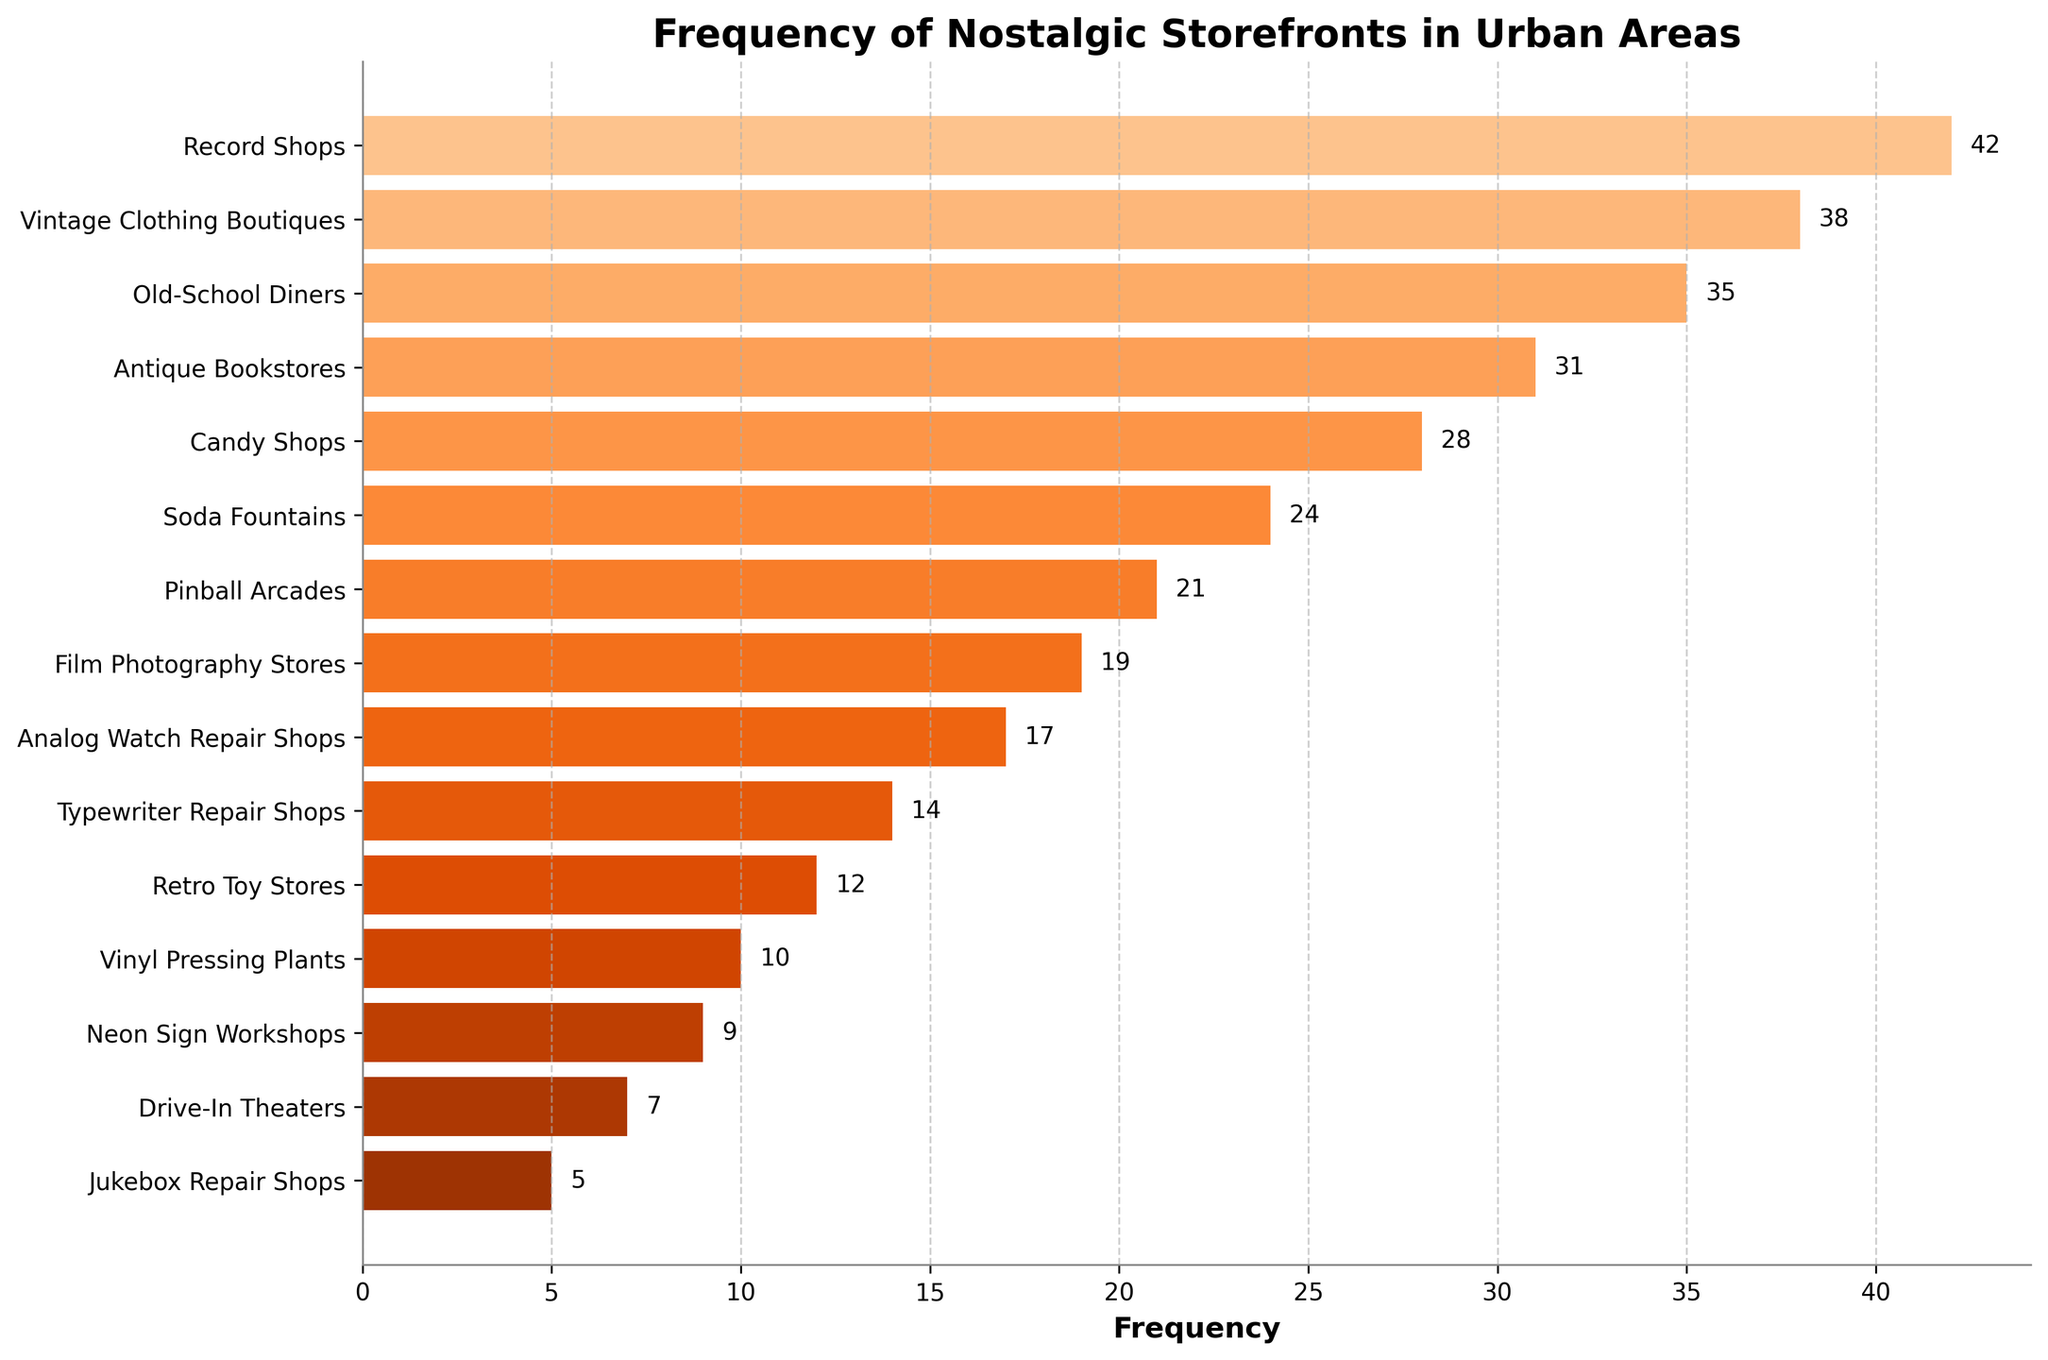What's the most frequent nostalgic storefront type captured? To find the most frequent storefront type, look for the bar with the greatest length. "Record Shops" have the highest frequency in the chart.
Answer: Record Shops Which storefront type has a lower frequency: "Candy Shops" or "Soda Fountains"? Compare the lengths of the bars for "Candy Shops" and "Soda Fountains". "Soda Fountains" has a shorter bar than "Candy Shops".
Answer: Soda Fountains How much greater is the frequency of "Old-School Diners" compared to "Analog Watch Repair Shops"? Subtract the frequency of "Analog Watch Repair Shops" (17) from the frequency of "Old-School Diners" (35): 35 - 17 = 18.
Answer: 18 What’s the average frequency of the top three most frequent nostalgic storefronts? The frequencies of the top three most frequent storefronts are: Record Shops (42), Vintage Clothing Boutiques (38), and Old-School Diners (35). Their sum is 42 + 38 + 35 = 115. The average is 115 / 3 = 38.33.
Answer: 38.33 Identify two storefront types whose combined frequency equals that of "Pinball Arcades". "Pinball Arcades" has a frequency of 21. "Typewriter Repair Shops" (14) and "Analog Watch Repair Shops" (17) can be checked: 14 + 17 = 31 (too high), "Candy Shops" (28) and "Typewriter Repair Shops" (14) give 28 + 14 = 42 (too high). After checking various combinations, "Film Photography Stores" (19) and "Jukebox Repair Shops" (5) yield 19 + 5 = 24 (too high). Eventually, "Soda Fountains" (24) works perfectly with "Jukebox Repair Shops" (5): 24 + 5 = 21.
Answer: Soda Fountains and Jukebox Repair Shops Which is more frequent: "Retro Toy Stores" or the combined frequency of "Neon Sign Workshops" and "Drive-In Theaters"? The frequency of "Retro Toy Stores" is 12. The frequency of "Neon Sign Workshops" is 9 and "Drive-In Theaters" is 7: 9 + 7 = 16. Hence, the combined frequency (16) is greater than "Retro Toy Stores" (12).
Answer: Neon Sign Workshops and Drive-In Theaters combined Arrange the top five nostalgic storefronts from most to least frequent. Identify the top five frequencies: Record Shops (42), Vintage Clothing Boutiques (38), Old-School Diners (35), Antique Bookstores (31), and Candy Shops (28).
Answer: Record Shops, Vintage Clothing Boutiques, Old-School Diners, Antique Bookstores, Candy Shops How many storefront types have a frequency greater than 25? Identify and count the storefront types with frequencies above 25. They are: Record Shops (42), Vintage Clothing Boutiques (38), Old-School Diners (35), Antique Bookstores (31), and Candy Shops (28). There are 5 such types.
Answer: 5 